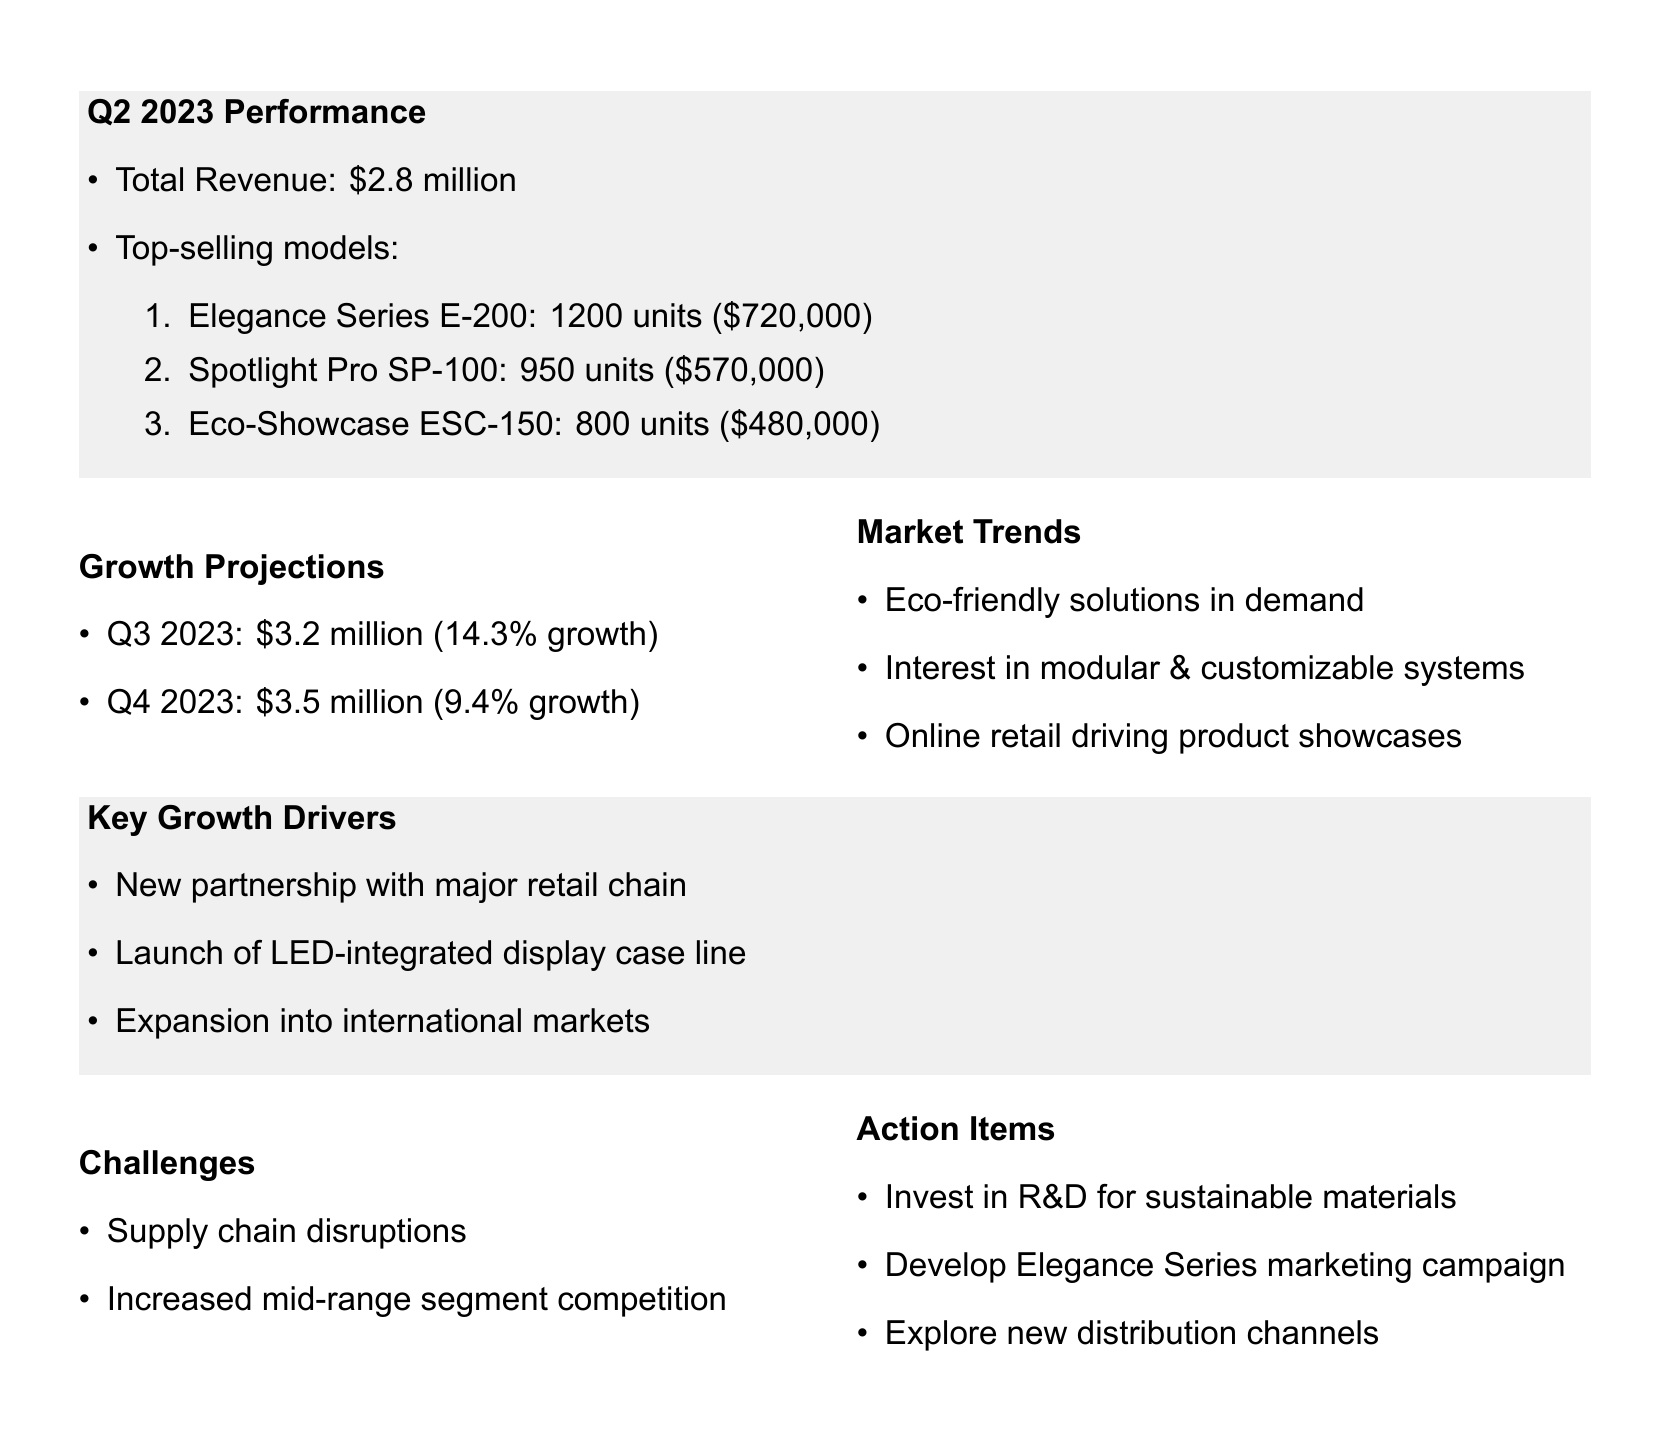what is the total revenue for Q2 2023? The document states the total revenue for Q2 2023 is $2.8 million.
Answer: $2.8 million how many units of the Elegance Series E-200 were sold? According to the document, 1200 units of the Elegance Series E-200 were sold.
Answer: 1200 units what is the estimated revenue for Q4 2023? The estimated revenue for Q4 2023 is explicitly mentioned in the document as $3.5 million.
Answer: $3.5 million what is the growth rate projected for Q3 2023? The document shows a growth rate projected for Q3 2023 of 14.3%.
Answer: 14.3% which model had the highest revenue in Q2 2023? From the sales data, the model with the highest revenue in Q2 2023 is the Elegance Series E-200 with $720,000.
Answer: Elegance Series E-200 what is one market trend mentioned in the document? The document lists increasing demand for eco-friendly display solutions as one of the market trends.
Answer: Increasing demand for eco-friendly display solutions what is a key growth driver for DisplayCraft Solutions? A key growth driver mentioned is the new partnership with a major retail chain.
Answer: New partnership with major retail chain what challenge is mentioned regarding material costs? The document mentions supply chain disruptions affecting material costs as a challenge.
Answer: Supply chain disruptions what action item involves marketing? The document indicates that there is an action item to develop a targeted marketing campaign for the Elegance Series.
Answer: Develop targeted marketing campaign for Elegance Series 